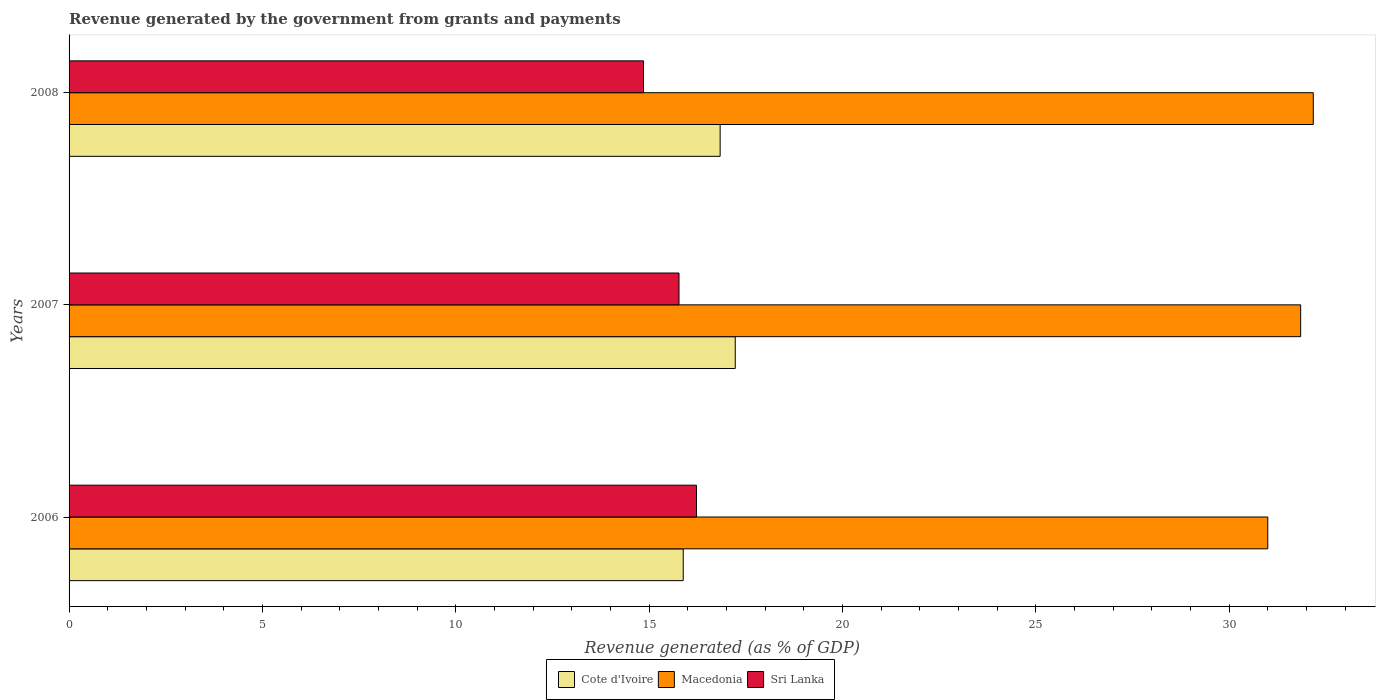How many different coloured bars are there?
Provide a succinct answer. 3. Are the number of bars per tick equal to the number of legend labels?
Provide a succinct answer. Yes. What is the label of the 2nd group of bars from the top?
Make the answer very short. 2007. In how many cases, is the number of bars for a given year not equal to the number of legend labels?
Give a very brief answer. 0. What is the revenue generated by the government in Sri Lanka in 2007?
Provide a succinct answer. 15.77. Across all years, what is the maximum revenue generated by the government in Macedonia?
Offer a very short reply. 32.18. Across all years, what is the minimum revenue generated by the government in Macedonia?
Your response must be concise. 31. In which year was the revenue generated by the government in Macedonia maximum?
Provide a succinct answer. 2008. What is the total revenue generated by the government in Cote d'Ivoire in the graph?
Ensure brevity in your answer.  49.95. What is the difference between the revenue generated by the government in Macedonia in 2006 and that in 2008?
Keep it short and to the point. -1.18. What is the difference between the revenue generated by the government in Sri Lanka in 2006 and the revenue generated by the government in Macedonia in 2008?
Your answer should be very brief. -15.95. What is the average revenue generated by the government in Cote d'Ivoire per year?
Offer a very short reply. 16.65. In the year 2006, what is the difference between the revenue generated by the government in Sri Lanka and revenue generated by the government in Cote d'Ivoire?
Provide a short and direct response. 0.34. What is the ratio of the revenue generated by the government in Macedonia in 2006 to that in 2008?
Keep it short and to the point. 0.96. Is the difference between the revenue generated by the government in Sri Lanka in 2006 and 2007 greater than the difference between the revenue generated by the government in Cote d'Ivoire in 2006 and 2007?
Your response must be concise. Yes. What is the difference between the highest and the second highest revenue generated by the government in Cote d'Ivoire?
Provide a succinct answer. 0.39. What is the difference between the highest and the lowest revenue generated by the government in Cote d'Ivoire?
Provide a succinct answer. 1.34. In how many years, is the revenue generated by the government in Macedonia greater than the average revenue generated by the government in Macedonia taken over all years?
Offer a terse response. 2. Is the sum of the revenue generated by the government in Macedonia in 2007 and 2008 greater than the maximum revenue generated by the government in Sri Lanka across all years?
Offer a terse response. Yes. What does the 3rd bar from the top in 2007 represents?
Your response must be concise. Cote d'Ivoire. What does the 1st bar from the bottom in 2006 represents?
Provide a succinct answer. Cote d'Ivoire. Is it the case that in every year, the sum of the revenue generated by the government in Macedonia and revenue generated by the government in Sri Lanka is greater than the revenue generated by the government in Cote d'Ivoire?
Give a very brief answer. Yes. How many bars are there?
Provide a succinct answer. 9. What is the difference between two consecutive major ticks on the X-axis?
Offer a terse response. 5. Are the values on the major ticks of X-axis written in scientific E-notation?
Make the answer very short. No. Does the graph contain any zero values?
Keep it short and to the point. No. How many legend labels are there?
Offer a very short reply. 3. What is the title of the graph?
Ensure brevity in your answer.  Revenue generated by the government from grants and payments. Does "Liechtenstein" appear as one of the legend labels in the graph?
Your answer should be compact. No. What is the label or title of the X-axis?
Make the answer very short. Revenue generated (as % of GDP). What is the Revenue generated (as % of GDP) in Cote d'Ivoire in 2006?
Give a very brief answer. 15.88. What is the Revenue generated (as % of GDP) in Macedonia in 2006?
Make the answer very short. 31. What is the Revenue generated (as % of GDP) of Sri Lanka in 2006?
Keep it short and to the point. 16.23. What is the Revenue generated (as % of GDP) in Cote d'Ivoire in 2007?
Offer a terse response. 17.23. What is the Revenue generated (as % of GDP) of Macedonia in 2007?
Keep it short and to the point. 31.85. What is the Revenue generated (as % of GDP) of Sri Lanka in 2007?
Ensure brevity in your answer.  15.77. What is the Revenue generated (as % of GDP) of Cote d'Ivoire in 2008?
Your answer should be compact. 16.84. What is the Revenue generated (as % of GDP) of Macedonia in 2008?
Ensure brevity in your answer.  32.18. What is the Revenue generated (as % of GDP) in Sri Lanka in 2008?
Offer a terse response. 14.86. Across all years, what is the maximum Revenue generated (as % of GDP) of Cote d'Ivoire?
Offer a very short reply. 17.23. Across all years, what is the maximum Revenue generated (as % of GDP) of Macedonia?
Your answer should be very brief. 32.18. Across all years, what is the maximum Revenue generated (as % of GDP) in Sri Lanka?
Offer a terse response. 16.23. Across all years, what is the minimum Revenue generated (as % of GDP) of Cote d'Ivoire?
Make the answer very short. 15.88. Across all years, what is the minimum Revenue generated (as % of GDP) in Macedonia?
Give a very brief answer. 31. Across all years, what is the minimum Revenue generated (as % of GDP) in Sri Lanka?
Make the answer very short. 14.86. What is the total Revenue generated (as % of GDP) in Cote d'Ivoire in the graph?
Ensure brevity in your answer.  49.95. What is the total Revenue generated (as % of GDP) in Macedonia in the graph?
Ensure brevity in your answer.  95.03. What is the total Revenue generated (as % of GDP) of Sri Lanka in the graph?
Provide a succinct answer. 46.86. What is the difference between the Revenue generated (as % of GDP) in Cote d'Ivoire in 2006 and that in 2007?
Your response must be concise. -1.34. What is the difference between the Revenue generated (as % of GDP) in Macedonia in 2006 and that in 2007?
Your answer should be very brief. -0.85. What is the difference between the Revenue generated (as % of GDP) in Sri Lanka in 2006 and that in 2007?
Offer a terse response. 0.45. What is the difference between the Revenue generated (as % of GDP) of Cote d'Ivoire in 2006 and that in 2008?
Offer a very short reply. -0.95. What is the difference between the Revenue generated (as % of GDP) of Macedonia in 2006 and that in 2008?
Your answer should be very brief. -1.18. What is the difference between the Revenue generated (as % of GDP) of Sri Lanka in 2006 and that in 2008?
Keep it short and to the point. 1.37. What is the difference between the Revenue generated (as % of GDP) in Cote d'Ivoire in 2007 and that in 2008?
Give a very brief answer. 0.39. What is the difference between the Revenue generated (as % of GDP) in Macedonia in 2007 and that in 2008?
Your response must be concise. -0.33. What is the difference between the Revenue generated (as % of GDP) in Sri Lanka in 2007 and that in 2008?
Offer a very short reply. 0.92. What is the difference between the Revenue generated (as % of GDP) in Cote d'Ivoire in 2006 and the Revenue generated (as % of GDP) in Macedonia in 2007?
Provide a succinct answer. -15.97. What is the difference between the Revenue generated (as % of GDP) of Cote d'Ivoire in 2006 and the Revenue generated (as % of GDP) of Sri Lanka in 2007?
Give a very brief answer. 0.11. What is the difference between the Revenue generated (as % of GDP) of Macedonia in 2006 and the Revenue generated (as % of GDP) of Sri Lanka in 2007?
Keep it short and to the point. 15.23. What is the difference between the Revenue generated (as % of GDP) of Cote d'Ivoire in 2006 and the Revenue generated (as % of GDP) of Macedonia in 2008?
Offer a terse response. -16.29. What is the difference between the Revenue generated (as % of GDP) of Cote d'Ivoire in 2006 and the Revenue generated (as % of GDP) of Sri Lanka in 2008?
Make the answer very short. 1.03. What is the difference between the Revenue generated (as % of GDP) of Macedonia in 2006 and the Revenue generated (as % of GDP) of Sri Lanka in 2008?
Your answer should be compact. 16.15. What is the difference between the Revenue generated (as % of GDP) of Cote d'Ivoire in 2007 and the Revenue generated (as % of GDP) of Macedonia in 2008?
Your answer should be compact. -14.95. What is the difference between the Revenue generated (as % of GDP) of Cote d'Ivoire in 2007 and the Revenue generated (as % of GDP) of Sri Lanka in 2008?
Your response must be concise. 2.37. What is the difference between the Revenue generated (as % of GDP) in Macedonia in 2007 and the Revenue generated (as % of GDP) in Sri Lanka in 2008?
Offer a terse response. 17. What is the average Revenue generated (as % of GDP) of Cote d'Ivoire per year?
Keep it short and to the point. 16.65. What is the average Revenue generated (as % of GDP) of Macedonia per year?
Ensure brevity in your answer.  31.68. What is the average Revenue generated (as % of GDP) in Sri Lanka per year?
Your answer should be very brief. 15.62. In the year 2006, what is the difference between the Revenue generated (as % of GDP) in Cote d'Ivoire and Revenue generated (as % of GDP) in Macedonia?
Ensure brevity in your answer.  -15.12. In the year 2006, what is the difference between the Revenue generated (as % of GDP) in Cote d'Ivoire and Revenue generated (as % of GDP) in Sri Lanka?
Your answer should be very brief. -0.34. In the year 2006, what is the difference between the Revenue generated (as % of GDP) of Macedonia and Revenue generated (as % of GDP) of Sri Lanka?
Provide a short and direct response. 14.78. In the year 2007, what is the difference between the Revenue generated (as % of GDP) of Cote d'Ivoire and Revenue generated (as % of GDP) of Macedonia?
Offer a terse response. -14.62. In the year 2007, what is the difference between the Revenue generated (as % of GDP) of Cote d'Ivoire and Revenue generated (as % of GDP) of Sri Lanka?
Provide a short and direct response. 1.45. In the year 2007, what is the difference between the Revenue generated (as % of GDP) in Macedonia and Revenue generated (as % of GDP) in Sri Lanka?
Give a very brief answer. 16.08. In the year 2008, what is the difference between the Revenue generated (as % of GDP) of Cote d'Ivoire and Revenue generated (as % of GDP) of Macedonia?
Give a very brief answer. -15.34. In the year 2008, what is the difference between the Revenue generated (as % of GDP) of Cote d'Ivoire and Revenue generated (as % of GDP) of Sri Lanka?
Give a very brief answer. 1.98. In the year 2008, what is the difference between the Revenue generated (as % of GDP) of Macedonia and Revenue generated (as % of GDP) of Sri Lanka?
Offer a very short reply. 17.32. What is the ratio of the Revenue generated (as % of GDP) of Cote d'Ivoire in 2006 to that in 2007?
Make the answer very short. 0.92. What is the ratio of the Revenue generated (as % of GDP) in Macedonia in 2006 to that in 2007?
Your answer should be very brief. 0.97. What is the ratio of the Revenue generated (as % of GDP) in Sri Lanka in 2006 to that in 2007?
Your answer should be compact. 1.03. What is the ratio of the Revenue generated (as % of GDP) in Cote d'Ivoire in 2006 to that in 2008?
Offer a terse response. 0.94. What is the ratio of the Revenue generated (as % of GDP) in Macedonia in 2006 to that in 2008?
Provide a succinct answer. 0.96. What is the ratio of the Revenue generated (as % of GDP) of Sri Lanka in 2006 to that in 2008?
Provide a short and direct response. 1.09. What is the ratio of the Revenue generated (as % of GDP) of Cote d'Ivoire in 2007 to that in 2008?
Offer a terse response. 1.02. What is the ratio of the Revenue generated (as % of GDP) of Sri Lanka in 2007 to that in 2008?
Offer a very short reply. 1.06. What is the difference between the highest and the second highest Revenue generated (as % of GDP) of Cote d'Ivoire?
Your answer should be very brief. 0.39. What is the difference between the highest and the second highest Revenue generated (as % of GDP) in Macedonia?
Your answer should be very brief. 0.33. What is the difference between the highest and the second highest Revenue generated (as % of GDP) in Sri Lanka?
Provide a succinct answer. 0.45. What is the difference between the highest and the lowest Revenue generated (as % of GDP) of Cote d'Ivoire?
Provide a short and direct response. 1.34. What is the difference between the highest and the lowest Revenue generated (as % of GDP) in Macedonia?
Provide a succinct answer. 1.18. What is the difference between the highest and the lowest Revenue generated (as % of GDP) of Sri Lanka?
Give a very brief answer. 1.37. 